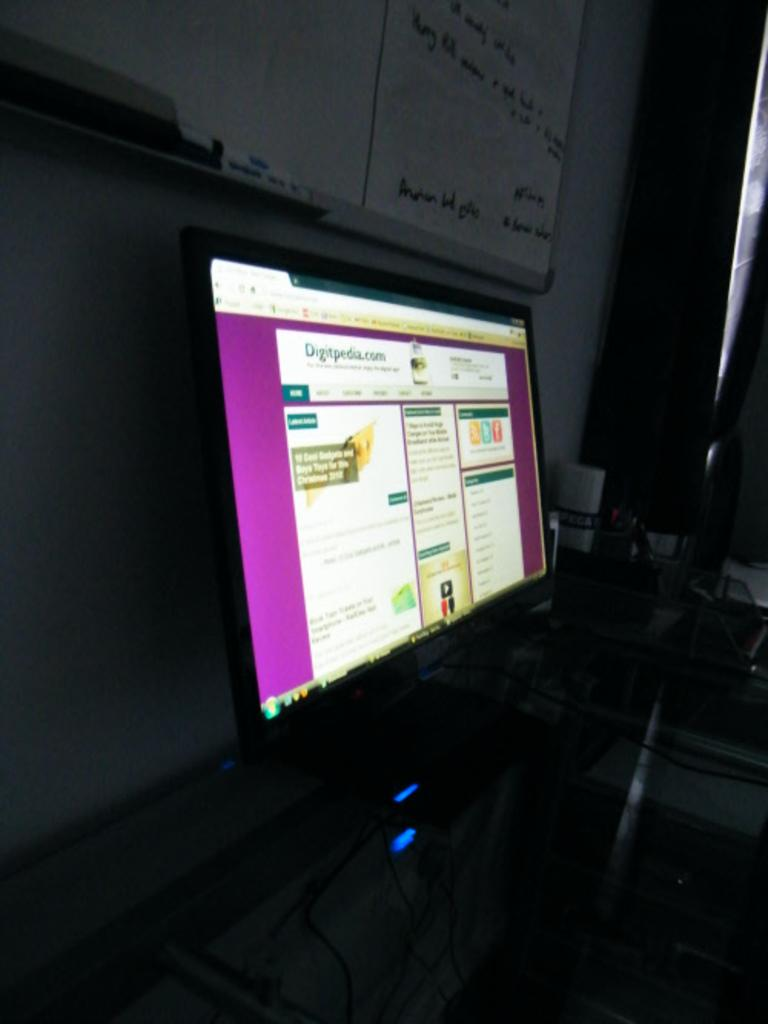What type of furniture is present in the image? There is a desktop in the image. What is displayed on the desktop? The desktop displays a picture. What is another object visible in the image? There is a whiteboard in the image. What can be seen on the whiteboard? The whiteboard has something written on it. What type of volcano can be seen erupting in the background of the image? There is no volcano present in the image; it only features a desktop and a whiteboard. What type of bushes are growing near the desktop in the image? There are no bushes visible in the image; it only features a desktop and a whiteboard. 